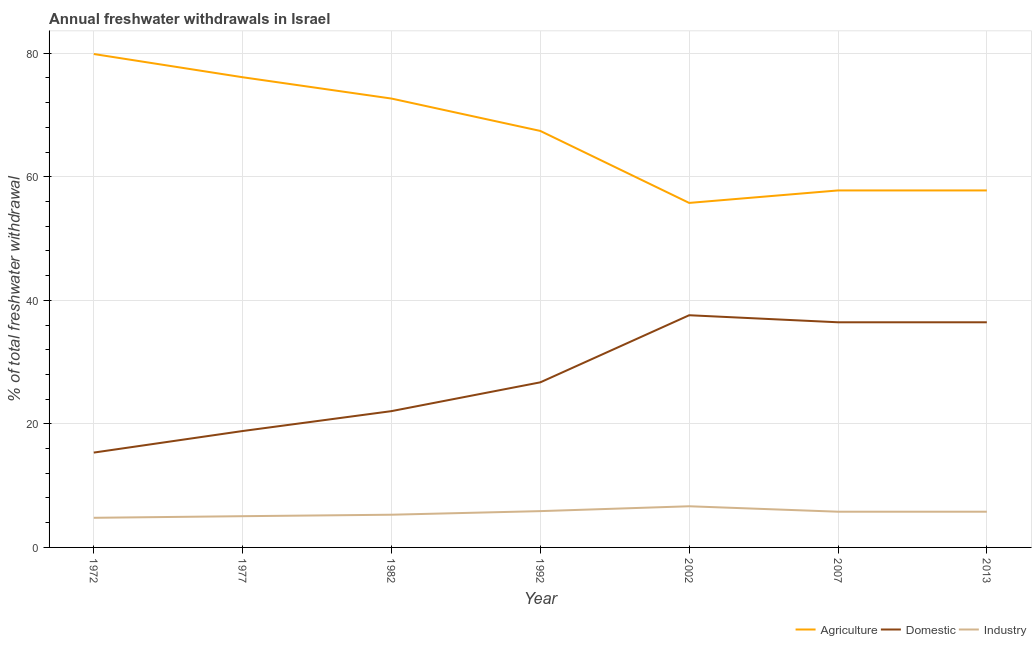How many different coloured lines are there?
Give a very brief answer. 3. Is the number of lines equal to the number of legend labels?
Give a very brief answer. Yes. What is the percentage of freshwater withdrawal for agriculture in 1992?
Offer a terse response. 67.41. Across all years, what is the maximum percentage of freshwater withdrawal for agriculture?
Your answer should be compact. 79.86. Across all years, what is the minimum percentage of freshwater withdrawal for domestic purposes?
Your answer should be compact. 15.35. In which year was the percentage of freshwater withdrawal for industry minimum?
Your response must be concise. 1972. What is the total percentage of freshwater withdrawal for industry in the graph?
Keep it short and to the point. 39.25. What is the difference between the percentage of freshwater withdrawal for industry in 1992 and that in 2007?
Give a very brief answer. 0.09. What is the difference between the percentage of freshwater withdrawal for industry in 1992 and the percentage of freshwater withdrawal for agriculture in 2002?
Offer a terse response. -49.88. What is the average percentage of freshwater withdrawal for agriculture per year?
Ensure brevity in your answer.  66.76. In the year 2007, what is the difference between the percentage of freshwater withdrawal for domestic purposes and percentage of freshwater withdrawal for industry?
Provide a short and direct response. 30.66. In how many years, is the percentage of freshwater withdrawal for industry greater than 60 %?
Provide a succinct answer. 0. What is the ratio of the percentage of freshwater withdrawal for industry in 1992 to that in 2002?
Offer a very short reply. 0.88. Is the percentage of freshwater withdrawal for domestic purposes in 1982 less than that in 1992?
Make the answer very short. Yes. Is the difference between the percentage of freshwater withdrawal for domestic purposes in 1977 and 2013 greater than the difference between the percentage of freshwater withdrawal for agriculture in 1977 and 2013?
Offer a terse response. No. What is the difference between the highest and the second highest percentage of freshwater withdrawal for agriculture?
Give a very brief answer. 3.76. What is the difference between the highest and the lowest percentage of freshwater withdrawal for domestic purposes?
Offer a terse response. 22.23. In how many years, is the percentage of freshwater withdrawal for agriculture greater than the average percentage of freshwater withdrawal for agriculture taken over all years?
Your answer should be very brief. 4. Is it the case that in every year, the sum of the percentage of freshwater withdrawal for agriculture and percentage of freshwater withdrawal for domestic purposes is greater than the percentage of freshwater withdrawal for industry?
Your response must be concise. Yes. Is the percentage of freshwater withdrawal for domestic purposes strictly greater than the percentage of freshwater withdrawal for industry over the years?
Provide a succinct answer. Yes. How many years are there in the graph?
Offer a very short reply. 7. What is the difference between two consecutive major ticks on the Y-axis?
Give a very brief answer. 20. Are the values on the major ticks of Y-axis written in scientific E-notation?
Make the answer very short. No. Does the graph contain grids?
Your answer should be compact. Yes. Where does the legend appear in the graph?
Make the answer very short. Bottom right. What is the title of the graph?
Your answer should be compact. Annual freshwater withdrawals in Israel. Does "Tertiary education" appear as one of the legend labels in the graph?
Your response must be concise. No. What is the label or title of the X-axis?
Your response must be concise. Year. What is the label or title of the Y-axis?
Make the answer very short. % of total freshwater withdrawal. What is the % of total freshwater withdrawal in Agriculture in 1972?
Keep it short and to the point. 79.86. What is the % of total freshwater withdrawal in Domestic in 1972?
Offer a very short reply. 15.35. What is the % of total freshwater withdrawal of Industry in 1972?
Offer a terse response. 4.79. What is the % of total freshwater withdrawal of Agriculture in 1977?
Keep it short and to the point. 76.1. What is the % of total freshwater withdrawal of Domestic in 1977?
Provide a succinct answer. 18.84. What is the % of total freshwater withdrawal of Industry in 1977?
Your answer should be very brief. 5.05. What is the % of total freshwater withdrawal in Agriculture in 1982?
Give a very brief answer. 72.65. What is the % of total freshwater withdrawal in Domestic in 1982?
Your answer should be compact. 22.06. What is the % of total freshwater withdrawal of Industry in 1982?
Provide a succinct answer. 5.29. What is the % of total freshwater withdrawal in Agriculture in 1992?
Provide a short and direct response. 67.41. What is the % of total freshwater withdrawal of Domestic in 1992?
Make the answer very short. 26.72. What is the % of total freshwater withdrawal in Industry in 1992?
Offer a very short reply. 5.88. What is the % of total freshwater withdrawal in Agriculture in 2002?
Keep it short and to the point. 55.76. What is the % of total freshwater withdrawal of Domestic in 2002?
Your response must be concise. 37.58. What is the % of total freshwater withdrawal in Industry in 2002?
Provide a short and direct response. 6.66. What is the % of total freshwater withdrawal of Agriculture in 2007?
Your response must be concise. 57.78. What is the % of total freshwater withdrawal in Domestic in 2007?
Offer a terse response. 36.44. What is the % of total freshwater withdrawal of Industry in 2007?
Your response must be concise. 5.78. What is the % of total freshwater withdrawal of Agriculture in 2013?
Provide a succinct answer. 57.78. What is the % of total freshwater withdrawal of Domestic in 2013?
Provide a succinct answer. 36.44. What is the % of total freshwater withdrawal of Industry in 2013?
Your answer should be very brief. 5.78. Across all years, what is the maximum % of total freshwater withdrawal of Agriculture?
Provide a short and direct response. 79.86. Across all years, what is the maximum % of total freshwater withdrawal of Domestic?
Make the answer very short. 37.58. Across all years, what is the maximum % of total freshwater withdrawal of Industry?
Make the answer very short. 6.66. Across all years, what is the minimum % of total freshwater withdrawal in Agriculture?
Offer a terse response. 55.76. Across all years, what is the minimum % of total freshwater withdrawal in Domestic?
Ensure brevity in your answer.  15.35. Across all years, what is the minimum % of total freshwater withdrawal in Industry?
Keep it short and to the point. 4.79. What is the total % of total freshwater withdrawal of Agriculture in the graph?
Provide a short and direct response. 467.34. What is the total % of total freshwater withdrawal in Domestic in the graph?
Offer a terse response. 193.43. What is the total % of total freshwater withdrawal of Industry in the graph?
Your response must be concise. 39.25. What is the difference between the % of total freshwater withdrawal in Agriculture in 1972 and that in 1977?
Provide a short and direct response. 3.76. What is the difference between the % of total freshwater withdrawal in Domestic in 1972 and that in 1977?
Make the answer very short. -3.49. What is the difference between the % of total freshwater withdrawal of Industry in 1972 and that in 1977?
Provide a short and direct response. -0.26. What is the difference between the % of total freshwater withdrawal in Agriculture in 1972 and that in 1982?
Provide a succinct answer. 7.21. What is the difference between the % of total freshwater withdrawal in Domestic in 1972 and that in 1982?
Your answer should be compact. -6.71. What is the difference between the % of total freshwater withdrawal of Industry in 1972 and that in 1982?
Offer a very short reply. -0.5. What is the difference between the % of total freshwater withdrawal in Agriculture in 1972 and that in 1992?
Offer a very short reply. 12.45. What is the difference between the % of total freshwater withdrawal of Domestic in 1972 and that in 1992?
Give a very brief answer. -11.37. What is the difference between the % of total freshwater withdrawal of Industry in 1972 and that in 1992?
Your answer should be compact. -1.08. What is the difference between the % of total freshwater withdrawal in Agriculture in 1972 and that in 2002?
Offer a very short reply. 24.1. What is the difference between the % of total freshwater withdrawal in Domestic in 1972 and that in 2002?
Offer a terse response. -22.23. What is the difference between the % of total freshwater withdrawal of Industry in 1972 and that in 2002?
Your response must be concise. -1.87. What is the difference between the % of total freshwater withdrawal in Agriculture in 1972 and that in 2007?
Ensure brevity in your answer.  22.08. What is the difference between the % of total freshwater withdrawal in Domestic in 1972 and that in 2007?
Your answer should be very brief. -21.09. What is the difference between the % of total freshwater withdrawal of Industry in 1972 and that in 2007?
Your answer should be very brief. -0.99. What is the difference between the % of total freshwater withdrawal in Agriculture in 1972 and that in 2013?
Offer a very short reply. 22.08. What is the difference between the % of total freshwater withdrawal of Domestic in 1972 and that in 2013?
Your response must be concise. -21.09. What is the difference between the % of total freshwater withdrawal in Industry in 1972 and that in 2013?
Provide a short and direct response. -0.99. What is the difference between the % of total freshwater withdrawal in Agriculture in 1977 and that in 1982?
Your response must be concise. 3.45. What is the difference between the % of total freshwater withdrawal in Domestic in 1977 and that in 1982?
Provide a succinct answer. -3.22. What is the difference between the % of total freshwater withdrawal of Industry in 1977 and that in 1982?
Give a very brief answer. -0.24. What is the difference between the % of total freshwater withdrawal of Agriculture in 1977 and that in 1992?
Your response must be concise. 8.69. What is the difference between the % of total freshwater withdrawal in Domestic in 1977 and that in 1992?
Ensure brevity in your answer.  -7.88. What is the difference between the % of total freshwater withdrawal in Industry in 1977 and that in 1992?
Make the answer very short. -0.82. What is the difference between the % of total freshwater withdrawal in Agriculture in 1977 and that in 2002?
Your response must be concise. 20.34. What is the difference between the % of total freshwater withdrawal of Domestic in 1977 and that in 2002?
Keep it short and to the point. -18.74. What is the difference between the % of total freshwater withdrawal in Industry in 1977 and that in 2002?
Offer a terse response. -1.61. What is the difference between the % of total freshwater withdrawal in Agriculture in 1977 and that in 2007?
Provide a short and direct response. 18.32. What is the difference between the % of total freshwater withdrawal of Domestic in 1977 and that in 2007?
Your answer should be compact. -17.6. What is the difference between the % of total freshwater withdrawal of Industry in 1977 and that in 2007?
Provide a short and direct response. -0.73. What is the difference between the % of total freshwater withdrawal in Agriculture in 1977 and that in 2013?
Ensure brevity in your answer.  18.32. What is the difference between the % of total freshwater withdrawal of Domestic in 1977 and that in 2013?
Provide a succinct answer. -17.6. What is the difference between the % of total freshwater withdrawal in Industry in 1977 and that in 2013?
Your answer should be very brief. -0.73. What is the difference between the % of total freshwater withdrawal of Agriculture in 1982 and that in 1992?
Provide a succinct answer. 5.24. What is the difference between the % of total freshwater withdrawal in Domestic in 1982 and that in 1992?
Offer a terse response. -4.66. What is the difference between the % of total freshwater withdrawal of Industry in 1982 and that in 1992?
Offer a terse response. -0.58. What is the difference between the % of total freshwater withdrawal in Agriculture in 1982 and that in 2002?
Offer a terse response. 16.89. What is the difference between the % of total freshwater withdrawal of Domestic in 1982 and that in 2002?
Offer a terse response. -15.52. What is the difference between the % of total freshwater withdrawal of Industry in 1982 and that in 2002?
Give a very brief answer. -1.37. What is the difference between the % of total freshwater withdrawal of Agriculture in 1982 and that in 2007?
Make the answer very short. 14.87. What is the difference between the % of total freshwater withdrawal of Domestic in 1982 and that in 2007?
Offer a terse response. -14.38. What is the difference between the % of total freshwater withdrawal in Industry in 1982 and that in 2007?
Offer a very short reply. -0.49. What is the difference between the % of total freshwater withdrawal in Agriculture in 1982 and that in 2013?
Make the answer very short. 14.87. What is the difference between the % of total freshwater withdrawal of Domestic in 1982 and that in 2013?
Ensure brevity in your answer.  -14.38. What is the difference between the % of total freshwater withdrawal of Industry in 1982 and that in 2013?
Your answer should be very brief. -0.49. What is the difference between the % of total freshwater withdrawal of Agriculture in 1992 and that in 2002?
Your answer should be very brief. 11.65. What is the difference between the % of total freshwater withdrawal in Domestic in 1992 and that in 2002?
Keep it short and to the point. -10.86. What is the difference between the % of total freshwater withdrawal in Industry in 1992 and that in 2002?
Make the answer very short. -0.79. What is the difference between the % of total freshwater withdrawal of Agriculture in 1992 and that in 2007?
Ensure brevity in your answer.  9.63. What is the difference between the % of total freshwater withdrawal of Domestic in 1992 and that in 2007?
Offer a very short reply. -9.72. What is the difference between the % of total freshwater withdrawal in Industry in 1992 and that in 2007?
Ensure brevity in your answer.  0.09. What is the difference between the % of total freshwater withdrawal of Agriculture in 1992 and that in 2013?
Provide a short and direct response. 9.63. What is the difference between the % of total freshwater withdrawal in Domestic in 1992 and that in 2013?
Ensure brevity in your answer.  -9.72. What is the difference between the % of total freshwater withdrawal of Industry in 1992 and that in 2013?
Keep it short and to the point. 0.09. What is the difference between the % of total freshwater withdrawal in Agriculture in 2002 and that in 2007?
Offer a terse response. -2.02. What is the difference between the % of total freshwater withdrawal of Domestic in 2002 and that in 2007?
Offer a very short reply. 1.14. What is the difference between the % of total freshwater withdrawal of Industry in 2002 and that in 2007?
Offer a terse response. 0.88. What is the difference between the % of total freshwater withdrawal in Agriculture in 2002 and that in 2013?
Offer a terse response. -2.02. What is the difference between the % of total freshwater withdrawal of Domestic in 2002 and that in 2013?
Your answer should be compact. 1.14. What is the difference between the % of total freshwater withdrawal of Agriculture in 2007 and that in 2013?
Offer a terse response. 0. What is the difference between the % of total freshwater withdrawal in Domestic in 2007 and that in 2013?
Ensure brevity in your answer.  0. What is the difference between the % of total freshwater withdrawal in Industry in 2007 and that in 2013?
Offer a very short reply. 0. What is the difference between the % of total freshwater withdrawal of Agriculture in 1972 and the % of total freshwater withdrawal of Domestic in 1977?
Provide a short and direct response. 61.02. What is the difference between the % of total freshwater withdrawal in Agriculture in 1972 and the % of total freshwater withdrawal in Industry in 1977?
Offer a very short reply. 74.81. What is the difference between the % of total freshwater withdrawal of Domestic in 1972 and the % of total freshwater withdrawal of Industry in 1977?
Provide a succinct answer. 10.29. What is the difference between the % of total freshwater withdrawal in Agriculture in 1972 and the % of total freshwater withdrawal in Domestic in 1982?
Your answer should be very brief. 57.8. What is the difference between the % of total freshwater withdrawal in Agriculture in 1972 and the % of total freshwater withdrawal in Industry in 1982?
Your answer should be very brief. 74.57. What is the difference between the % of total freshwater withdrawal of Domestic in 1972 and the % of total freshwater withdrawal of Industry in 1982?
Give a very brief answer. 10.06. What is the difference between the % of total freshwater withdrawal of Agriculture in 1972 and the % of total freshwater withdrawal of Domestic in 1992?
Provide a succinct answer. 53.14. What is the difference between the % of total freshwater withdrawal of Agriculture in 1972 and the % of total freshwater withdrawal of Industry in 1992?
Give a very brief answer. 73.98. What is the difference between the % of total freshwater withdrawal of Domestic in 1972 and the % of total freshwater withdrawal of Industry in 1992?
Keep it short and to the point. 9.47. What is the difference between the % of total freshwater withdrawal in Agriculture in 1972 and the % of total freshwater withdrawal in Domestic in 2002?
Your answer should be compact. 42.28. What is the difference between the % of total freshwater withdrawal in Agriculture in 1972 and the % of total freshwater withdrawal in Industry in 2002?
Provide a short and direct response. 73.2. What is the difference between the % of total freshwater withdrawal of Domestic in 1972 and the % of total freshwater withdrawal of Industry in 2002?
Your answer should be compact. 8.69. What is the difference between the % of total freshwater withdrawal of Agriculture in 1972 and the % of total freshwater withdrawal of Domestic in 2007?
Provide a short and direct response. 43.42. What is the difference between the % of total freshwater withdrawal of Agriculture in 1972 and the % of total freshwater withdrawal of Industry in 2007?
Ensure brevity in your answer.  74.08. What is the difference between the % of total freshwater withdrawal in Domestic in 1972 and the % of total freshwater withdrawal in Industry in 2007?
Make the answer very short. 9.57. What is the difference between the % of total freshwater withdrawal of Agriculture in 1972 and the % of total freshwater withdrawal of Domestic in 2013?
Your answer should be very brief. 43.42. What is the difference between the % of total freshwater withdrawal in Agriculture in 1972 and the % of total freshwater withdrawal in Industry in 2013?
Ensure brevity in your answer.  74.08. What is the difference between the % of total freshwater withdrawal in Domestic in 1972 and the % of total freshwater withdrawal in Industry in 2013?
Your answer should be very brief. 9.57. What is the difference between the % of total freshwater withdrawal in Agriculture in 1977 and the % of total freshwater withdrawal in Domestic in 1982?
Make the answer very short. 54.04. What is the difference between the % of total freshwater withdrawal of Agriculture in 1977 and the % of total freshwater withdrawal of Industry in 1982?
Offer a terse response. 70.81. What is the difference between the % of total freshwater withdrawal of Domestic in 1977 and the % of total freshwater withdrawal of Industry in 1982?
Provide a short and direct response. 13.55. What is the difference between the % of total freshwater withdrawal in Agriculture in 1977 and the % of total freshwater withdrawal in Domestic in 1992?
Your answer should be very brief. 49.38. What is the difference between the % of total freshwater withdrawal of Agriculture in 1977 and the % of total freshwater withdrawal of Industry in 1992?
Make the answer very short. 70.22. What is the difference between the % of total freshwater withdrawal in Domestic in 1977 and the % of total freshwater withdrawal in Industry in 1992?
Make the answer very short. 12.96. What is the difference between the % of total freshwater withdrawal in Agriculture in 1977 and the % of total freshwater withdrawal in Domestic in 2002?
Offer a terse response. 38.52. What is the difference between the % of total freshwater withdrawal of Agriculture in 1977 and the % of total freshwater withdrawal of Industry in 2002?
Make the answer very short. 69.44. What is the difference between the % of total freshwater withdrawal of Domestic in 1977 and the % of total freshwater withdrawal of Industry in 2002?
Your answer should be compact. 12.18. What is the difference between the % of total freshwater withdrawal in Agriculture in 1977 and the % of total freshwater withdrawal in Domestic in 2007?
Make the answer very short. 39.66. What is the difference between the % of total freshwater withdrawal of Agriculture in 1977 and the % of total freshwater withdrawal of Industry in 2007?
Your answer should be very brief. 70.32. What is the difference between the % of total freshwater withdrawal of Domestic in 1977 and the % of total freshwater withdrawal of Industry in 2007?
Offer a very short reply. 13.06. What is the difference between the % of total freshwater withdrawal of Agriculture in 1977 and the % of total freshwater withdrawal of Domestic in 2013?
Your response must be concise. 39.66. What is the difference between the % of total freshwater withdrawal in Agriculture in 1977 and the % of total freshwater withdrawal in Industry in 2013?
Provide a succinct answer. 70.32. What is the difference between the % of total freshwater withdrawal of Domestic in 1977 and the % of total freshwater withdrawal of Industry in 2013?
Keep it short and to the point. 13.06. What is the difference between the % of total freshwater withdrawal of Agriculture in 1982 and the % of total freshwater withdrawal of Domestic in 1992?
Offer a very short reply. 45.93. What is the difference between the % of total freshwater withdrawal of Agriculture in 1982 and the % of total freshwater withdrawal of Industry in 1992?
Ensure brevity in your answer.  66.77. What is the difference between the % of total freshwater withdrawal of Domestic in 1982 and the % of total freshwater withdrawal of Industry in 1992?
Keep it short and to the point. 16.18. What is the difference between the % of total freshwater withdrawal in Agriculture in 1982 and the % of total freshwater withdrawal in Domestic in 2002?
Provide a short and direct response. 35.07. What is the difference between the % of total freshwater withdrawal of Agriculture in 1982 and the % of total freshwater withdrawal of Industry in 2002?
Your response must be concise. 65.99. What is the difference between the % of total freshwater withdrawal in Domestic in 1982 and the % of total freshwater withdrawal in Industry in 2002?
Keep it short and to the point. 15.4. What is the difference between the % of total freshwater withdrawal in Agriculture in 1982 and the % of total freshwater withdrawal in Domestic in 2007?
Your answer should be very brief. 36.21. What is the difference between the % of total freshwater withdrawal of Agriculture in 1982 and the % of total freshwater withdrawal of Industry in 2007?
Your answer should be very brief. 66.87. What is the difference between the % of total freshwater withdrawal of Domestic in 1982 and the % of total freshwater withdrawal of Industry in 2007?
Your answer should be very brief. 16.28. What is the difference between the % of total freshwater withdrawal of Agriculture in 1982 and the % of total freshwater withdrawal of Domestic in 2013?
Keep it short and to the point. 36.21. What is the difference between the % of total freshwater withdrawal in Agriculture in 1982 and the % of total freshwater withdrawal in Industry in 2013?
Your answer should be very brief. 66.87. What is the difference between the % of total freshwater withdrawal of Domestic in 1982 and the % of total freshwater withdrawal of Industry in 2013?
Ensure brevity in your answer.  16.28. What is the difference between the % of total freshwater withdrawal of Agriculture in 1992 and the % of total freshwater withdrawal of Domestic in 2002?
Provide a short and direct response. 29.83. What is the difference between the % of total freshwater withdrawal of Agriculture in 1992 and the % of total freshwater withdrawal of Industry in 2002?
Your response must be concise. 60.75. What is the difference between the % of total freshwater withdrawal of Domestic in 1992 and the % of total freshwater withdrawal of Industry in 2002?
Offer a very short reply. 20.06. What is the difference between the % of total freshwater withdrawal of Agriculture in 1992 and the % of total freshwater withdrawal of Domestic in 2007?
Your answer should be compact. 30.97. What is the difference between the % of total freshwater withdrawal of Agriculture in 1992 and the % of total freshwater withdrawal of Industry in 2007?
Provide a succinct answer. 61.63. What is the difference between the % of total freshwater withdrawal in Domestic in 1992 and the % of total freshwater withdrawal in Industry in 2007?
Make the answer very short. 20.94. What is the difference between the % of total freshwater withdrawal in Agriculture in 1992 and the % of total freshwater withdrawal in Domestic in 2013?
Your answer should be very brief. 30.97. What is the difference between the % of total freshwater withdrawal of Agriculture in 1992 and the % of total freshwater withdrawal of Industry in 2013?
Make the answer very short. 61.63. What is the difference between the % of total freshwater withdrawal in Domestic in 1992 and the % of total freshwater withdrawal in Industry in 2013?
Make the answer very short. 20.94. What is the difference between the % of total freshwater withdrawal of Agriculture in 2002 and the % of total freshwater withdrawal of Domestic in 2007?
Your answer should be very brief. 19.32. What is the difference between the % of total freshwater withdrawal in Agriculture in 2002 and the % of total freshwater withdrawal in Industry in 2007?
Offer a terse response. 49.98. What is the difference between the % of total freshwater withdrawal in Domestic in 2002 and the % of total freshwater withdrawal in Industry in 2007?
Offer a terse response. 31.8. What is the difference between the % of total freshwater withdrawal in Agriculture in 2002 and the % of total freshwater withdrawal in Domestic in 2013?
Ensure brevity in your answer.  19.32. What is the difference between the % of total freshwater withdrawal in Agriculture in 2002 and the % of total freshwater withdrawal in Industry in 2013?
Your answer should be very brief. 49.98. What is the difference between the % of total freshwater withdrawal in Domestic in 2002 and the % of total freshwater withdrawal in Industry in 2013?
Your answer should be compact. 31.8. What is the difference between the % of total freshwater withdrawal of Agriculture in 2007 and the % of total freshwater withdrawal of Domestic in 2013?
Your answer should be very brief. 21.34. What is the difference between the % of total freshwater withdrawal in Agriculture in 2007 and the % of total freshwater withdrawal in Industry in 2013?
Offer a very short reply. 52. What is the difference between the % of total freshwater withdrawal of Domestic in 2007 and the % of total freshwater withdrawal of Industry in 2013?
Provide a short and direct response. 30.66. What is the average % of total freshwater withdrawal of Agriculture per year?
Your answer should be very brief. 66.76. What is the average % of total freshwater withdrawal in Domestic per year?
Your response must be concise. 27.63. What is the average % of total freshwater withdrawal of Industry per year?
Your answer should be very brief. 5.61. In the year 1972, what is the difference between the % of total freshwater withdrawal in Agriculture and % of total freshwater withdrawal in Domestic?
Your response must be concise. 64.51. In the year 1972, what is the difference between the % of total freshwater withdrawal of Agriculture and % of total freshwater withdrawal of Industry?
Provide a succinct answer. 75.06. In the year 1972, what is the difference between the % of total freshwater withdrawal in Domestic and % of total freshwater withdrawal in Industry?
Offer a terse response. 10.55. In the year 1977, what is the difference between the % of total freshwater withdrawal of Agriculture and % of total freshwater withdrawal of Domestic?
Offer a terse response. 57.26. In the year 1977, what is the difference between the % of total freshwater withdrawal of Agriculture and % of total freshwater withdrawal of Industry?
Give a very brief answer. 71.05. In the year 1977, what is the difference between the % of total freshwater withdrawal in Domestic and % of total freshwater withdrawal in Industry?
Offer a very short reply. 13.79. In the year 1982, what is the difference between the % of total freshwater withdrawal of Agriculture and % of total freshwater withdrawal of Domestic?
Keep it short and to the point. 50.59. In the year 1982, what is the difference between the % of total freshwater withdrawal in Agriculture and % of total freshwater withdrawal in Industry?
Provide a short and direct response. 67.36. In the year 1982, what is the difference between the % of total freshwater withdrawal in Domestic and % of total freshwater withdrawal in Industry?
Your answer should be compact. 16.77. In the year 1992, what is the difference between the % of total freshwater withdrawal of Agriculture and % of total freshwater withdrawal of Domestic?
Your answer should be compact. 40.69. In the year 1992, what is the difference between the % of total freshwater withdrawal of Agriculture and % of total freshwater withdrawal of Industry?
Make the answer very short. 61.53. In the year 1992, what is the difference between the % of total freshwater withdrawal of Domestic and % of total freshwater withdrawal of Industry?
Give a very brief answer. 20.84. In the year 2002, what is the difference between the % of total freshwater withdrawal of Agriculture and % of total freshwater withdrawal of Domestic?
Make the answer very short. 18.18. In the year 2002, what is the difference between the % of total freshwater withdrawal in Agriculture and % of total freshwater withdrawal in Industry?
Your answer should be compact. 49.1. In the year 2002, what is the difference between the % of total freshwater withdrawal of Domestic and % of total freshwater withdrawal of Industry?
Your response must be concise. 30.92. In the year 2007, what is the difference between the % of total freshwater withdrawal in Agriculture and % of total freshwater withdrawal in Domestic?
Ensure brevity in your answer.  21.34. In the year 2007, what is the difference between the % of total freshwater withdrawal in Agriculture and % of total freshwater withdrawal in Industry?
Keep it short and to the point. 52. In the year 2007, what is the difference between the % of total freshwater withdrawal of Domestic and % of total freshwater withdrawal of Industry?
Provide a succinct answer. 30.66. In the year 2013, what is the difference between the % of total freshwater withdrawal of Agriculture and % of total freshwater withdrawal of Domestic?
Offer a terse response. 21.34. In the year 2013, what is the difference between the % of total freshwater withdrawal of Agriculture and % of total freshwater withdrawal of Industry?
Your answer should be very brief. 52. In the year 2013, what is the difference between the % of total freshwater withdrawal of Domestic and % of total freshwater withdrawal of Industry?
Make the answer very short. 30.66. What is the ratio of the % of total freshwater withdrawal in Agriculture in 1972 to that in 1977?
Give a very brief answer. 1.05. What is the ratio of the % of total freshwater withdrawal in Domestic in 1972 to that in 1977?
Give a very brief answer. 0.81. What is the ratio of the % of total freshwater withdrawal of Industry in 1972 to that in 1977?
Provide a short and direct response. 0.95. What is the ratio of the % of total freshwater withdrawal of Agriculture in 1972 to that in 1982?
Provide a short and direct response. 1.1. What is the ratio of the % of total freshwater withdrawal in Domestic in 1972 to that in 1982?
Ensure brevity in your answer.  0.7. What is the ratio of the % of total freshwater withdrawal in Industry in 1972 to that in 1982?
Offer a very short reply. 0.91. What is the ratio of the % of total freshwater withdrawal in Agriculture in 1972 to that in 1992?
Give a very brief answer. 1.18. What is the ratio of the % of total freshwater withdrawal of Domestic in 1972 to that in 1992?
Give a very brief answer. 0.57. What is the ratio of the % of total freshwater withdrawal in Industry in 1972 to that in 1992?
Your answer should be very brief. 0.82. What is the ratio of the % of total freshwater withdrawal in Agriculture in 1972 to that in 2002?
Your response must be concise. 1.43. What is the ratio of the % of total freshwater withdrawal of Domestic in 1972 to that in 2002?
Offer a terse response. 0.41. What is the ratio of the % of total freshwater withdrawal in Industry in 1972 to that in 2002?
Provide a succinct answer. 0.72. What is the ratio of the % of total freshwater withdrawal in Agriculture in 1972 to that in 2007?
Give a very brief answer. 1.38. What is the ratio of the % of total freshwater withdrawal in Domestic in 1972 to that in 2007?
Your answer should be compact. 0.42. What is the ratio of the % of total freshwater withdrawal of Industry in 1972 to that in 2007?
Your answer should be compact. 0.83. What is the ratio of the % of total freshwater withdrawal in Agriculture in 1972 to that in 2013?
Provide a short and direct response. 1.38. What is the ratio of the % of total freshwater withdrawal in Domestic in 1972 to that in 2013?
Keep it short and to the point. 0.42. What is the ratio of the % of total freshwater withdrawal in Industry in 1972 to that in 2013?
Provide a succinct answer. 0.83. What is the ratio of the % of total freshwater withdrawal of Agriculture in 1977 to that in 1982?
Your answer should be very brief. 1.05. What is the ratio of the % of total freshwater withdrawal in Domestic in 1977 to that in 1982?
Provide a succinct answer. 0.85. What is the ratio of the % of total freshwater withdrawal in Industry in 1977 to that in 1982?
Your response must be concise. 0.95. What is the ratio of the % of total freshwater withdrawal in Agriculture in 1977 to that in 1992?
Ensure brevity in your answer.  1.13. What is the ratio of the % of total freshwater withdrawal of Domestic in 1977 to that in 1992?
Provide a short and direct response. 0.71. What is the ratio of the % of total freshwater withdrawal in Industry in 1977 to that in 1992?
Make the answer very short. 0.86. What is the ratio of the % of total freshwater withdrawal of Agriculture in 1977 to that in 2002?
Offer a very short reply. 1.36. What is the ratio of the % of total freshwater withdrawal in Domestic in 1977 to that in 2002?
Offer a very short reply. 0.5. What is the ratio of the % of total freshwater withdrawal of Industry in 1977 to that in 2002?
Offer a terse response. 0.76. What is the ratio of the % of total freshwater withdrawal in Agriculture in 1977 to that in 2007?
Keep it short and to the point. 1.32. What is the ratio of the % of total freshwater withdrawal of Domestic in 1977 to that in 2007?
Make the answer very short. 0.52. What is the ratio of the % of total freshwater withdrawal of Industry in 1977 to that in 2007?
Offer a terse response. 0.87. What is the ratio of the % of total freshwater withdrawal in Agriculture in 1977 to that in 2013?
Offer a terse response. 1.32. What is the ratio of the % of total freshwater withdrawal in Domestic in 1977 to that in 2013?
Provide a succinct answer. 0.52. What is the ratio of the % of total freshwater withdrawal in Industry in 1977 to that in 2013?
Give a very brief answer. 0.87. What is the ratio of the % of total freshwater withdrawal in Agriculture in 1982 to that in 1992?
Give a very brief answer. 1.08. What is the ratio of the % of total freshwater withdrawal in Domestic in 1982 to that in 1992?
Offer a very short reply. 0.83. What is the ratio of the % of total freshwater withdrawal of Industry in 1982 to that in 1992?
Offer a terse response. 0.9. What is the ratio of the % of total freshwater withdrawal of Agriculture in 1982 to that in 2002?
Keep it short and to the point. 1.3. What is the ratio of the % of total freshwater withdrawal of Domestic in 1982 to that in 2002?
Keep it short and to the point. 0.59. What is the ratio of the % of total freshwater withdrawal in Industry in 1982 to that in 2002?
Your answer should be very brief. 0.79. What is the ratio of the % of total freshwater withdrawal of Agriculture in 1982 to that in 2007?
Offer a terse response. 1.26. What is the ratio of the % of total freshwater withdrawal in Domestic in 1982 to that in 2007?
Your answer should be compact. 0.61. What is the ratio of the % of total freshwater withdrawal in Industry in 1982 to that in 2007?
Your response must be concise. 0.92. What is the ratio of the % of total freshwater withdrawal in Agriculture in 1982 to that in 2013?
Provide a short and direct response. 1.26. What is the ratio of the % of total freshwater withdrawal in Domestic in 1982 to that in 2013?
Keep it short and to the point. 0.61. What is the ratio of the % of total freshwater withdrawal in Industry in 1982 to that in 2013?
Ensure brevity in your answer.  0.92. What is the ratio of the % of total freshwater withdrawal in Agriculture in 1992 to that in 2002?
Give a very brief answer. 1.21. What is the ratio of the % of total freshwater withdrawal in Domestic in 1992 to that in 2002?
Your answer should be compact. 0.71. What is the ratio of the % of total freshwater withdrawal in Industry in 1992 to that in 2002?
Provide a succinct answer. 0.88. What is the ratio of the % of total freshwater withdrawal in Domestic in 1992 to that in 2007?
Ensure brevity in your answer.  0.73. What is the ratio of the % of total freshwater withdrawal of Industry in 1992 to that in 2007?
Keep it short and to the point. 1.02. What is the ratio of the % of total freshwater withdrawal in Agriculture in 1992 to that in 2013?
Your answer should be compact. 1.17. What is the ratio of the % of total freshwater withdrawal in Domestic in 1992 to that in 2013?
Give a very brief answer. 0.73. What is the ratio of the % of total freshwater withdrawal of Industry in 1992 to that in 2013?
Keep it short and to the point. 1.02. What is the ratio of the % of total freshwater withdrawal in Domestic in 2002 to that in 2007?
Your answer should be very brief. 1.03. What is the ratio of the % of total freshwater withdrawal of Industry in 2002 to that in 2007?
Your answer should be very brief. 1.15. What is the ratio of the % of total freshwater withdrawal of Domestic in 2002 to that in 2013?
Offer a very short reply. 1.03. What is the ratio of the % of total freshwater withdrawal in Industry in 2002 to that in 2013?
Ensure brevity in your answer.  1.15. What is the ratio of the % of total freshwater withdrawal in Agriculture in 2007 to that in 2013?
Make the answer very short. 1. What is the ratio of the % of total freshwater withdrawal in Domestic in 2007 to that in 2013?
Your answer should be very brief. 1. What is the difference between the highest and the second highest % of total freshwater withdrawal in Agriculture?
Your answer should be very brief. 3.76. What is the difference between the highest and the second highest % of total freshwater withdrawal of Domestic?
Give a very brief answer. 1.14. What is the difference between the highest and the second highest % of total freshwater withdrawal in Industry?
Your answer should be very brief. 0.79. What is the difference between the highest and the lowest % of total freshwater withdrawal of Agriculture?
Offer a terse response. 24.1. What is the difference between the highest and the lowest % of total freshwater withdrawal in Domestic?
Provide a short and direct response. 22.23. What is the difference between the highest and the lowest % of total freshwater withdrawal of Industry?
Give a very brief answer. 1.87. 